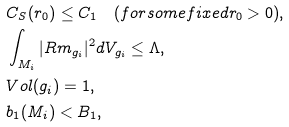Convert formula to latex. <formula><loc_0><loc_0><loc_500><loc_500>& C _ { S } ( r _ { 0 } ) \leq C _ { 1 } \quad ( f o r s o m e f i x e d r _ { 0 } > 0 ) , \\ & \int _ { M _ { i } } | R m _ { g _ { i } } | ^ { 2 } d V _ { g _ { i } } \leq \Lambda , \\ & V o l ( g _ { i } ) = 1 , \\ & b _ { 1 } ( M _ { i } ) < B _ { 1 } ,</formula> 